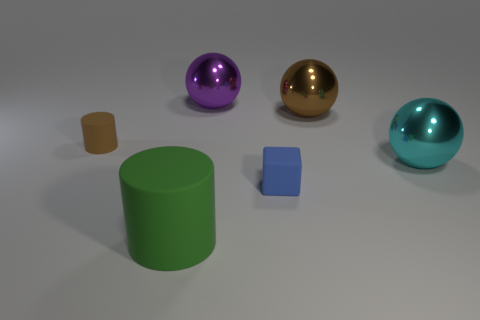What is the size of the rubber cylinder to the right of the brown rubber object?
Provide a short and direct response. Large. How many tiny cylinders are right of the rubber cylinder that is right of the rubber cylinder that is to the left of the large green rubber thing?
Offer a terse response. 0. Does the tiny matte block have the same color as the big matte cylinder?
Your answer should be compact. No. What number of big things are both to the right of the tiny blue rubber block and to the left of the brown metal ball?
Your answer should be compact. 0. There is a shiny thing to the right of the big brown shiny object; what shape is it?
Ensure brevity in your answer.  Sphere. Are there fewer things behind the big cyan sphere than purple shiny balls that are to the right of the blue object?
Your answer should be very brief. No. Do the cylinder that is behind the large green matte cylinder and the tiny thing that is to the right of the large purple thing have the same material?
Offer a terse response. Yes. What is the shape of the tiny brown matte object?
Provide a succinct answer. Cylinder. Are there more tiny rubber objects left of the tiny blue matte block than green things that are behind the big cyan ball?
Your answer should be very brief. Yes. Do the metallic object that is behind the brown shiny ball and the object on the right side of the brown sphere have the same shape?
Offer a very short reply. Yes. 